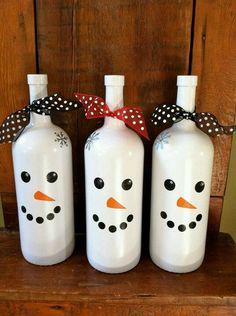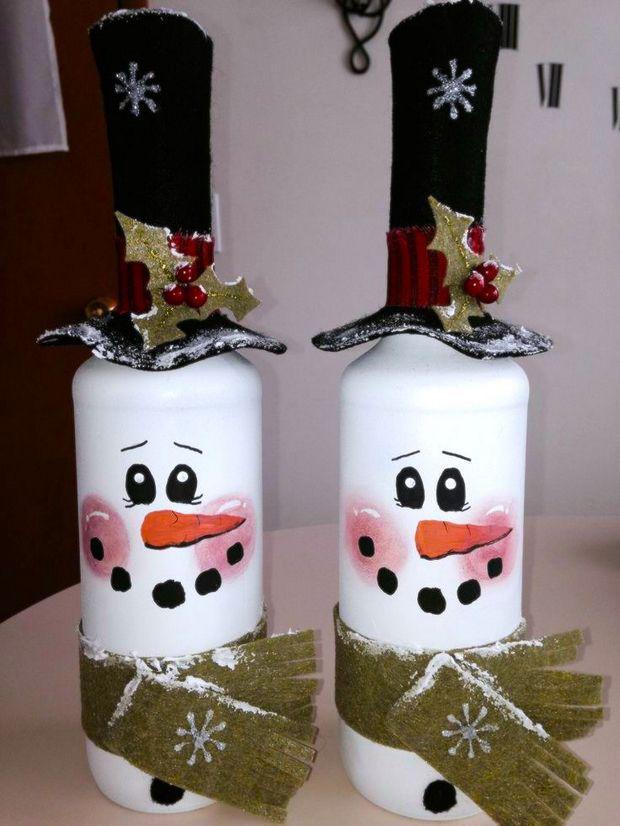The first image is the image on the left, the second image is the image on the right. Given the left and right images, does the statement "All of the bottles look like snowmen." hold true? Answer yes or no. Yes. 